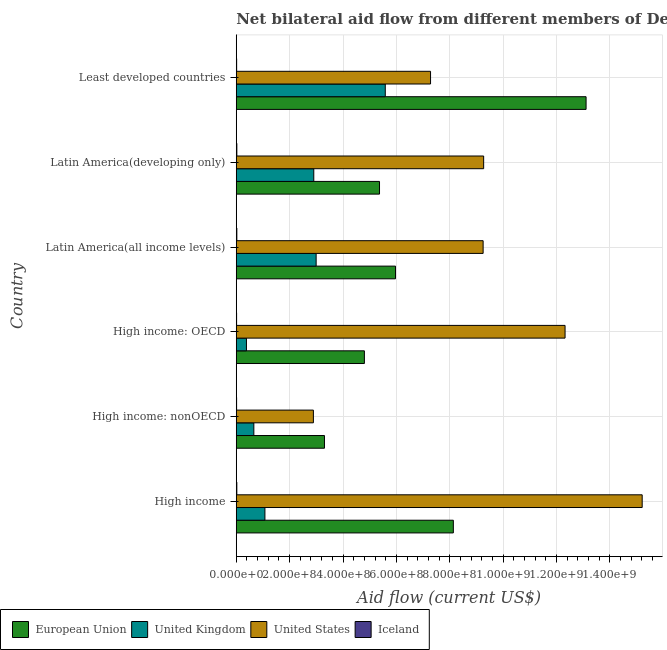How many different coloured bars are there?
Your answer should be very brief. 4. Are the number of bars per tick equal to the number of legend labels?
Provide a short and direct response. Yes. Are the number of bars on each tick of the Y-axis equal?
Ensure brevity in your answer.  Yes. How many bars are there on the 4th tick from the top?
Offer a terse response. 4. How many bars are there on the 3rd tick from the bottom?
Your answer should be compact. 4. What is the label of the 1st group of bars from the top?
Your response must be concise. Least developed countries. What is the amount of aid given by eu in High income: nonOECD?
Provide a succinct answer. 3.30e+08. Across all countries, what is the maximum amount of aid given by iceland?
Make the answer very short. 2.20e+06. Across all countries, what is the minimum amount of aid given by iceland?
Offer a terse response. 1.30e+06. In which country was the amount of aid given by eu maximum?
Provide a short and direct response. Least developed countries. In which country was the amount of aid given by us minimum?
Offer a terse response. High income: nonOECD. What is the total amount of aid given by eu in the graph?
Ensure brevity in your answer.  4.07e+09. What is the difference between the amount of aid given by iceland in High income and that in Latin America(developing only)?
Provide a short and direct response. -2.00e+04. What is the difference between the amount of aid given by us in Latin America(developing only) and the amount of aid given by uk in Latin America(all income levels)?
Offer a very short reply. 6.28e+08. What is the average amount of aid given by eu per country?
Your answer should be compact. 6.78e+08. What is the difference between the amount of aid given by us and amount of aid given by eu in Latin America(developing only)?
Your response must be concise. 3.90e+08. In how many countries, is the amount of aid given by eu greater than 480000000 US$?
Offer a very short reply. 5. What is the ratio of the amount of aid given by eu in High income: nonOECD to that in Least developed countries?
Provide a short and direct response. 0.25. Is the difference between the amount of aid given by eu in High income and High income: nonOECD greater than the difference between the amount of aid given by iceland in High income and High income: nonOECD?
Offer a very short reply. Yes. What is the difference between the highest and the second highest amount of aid given by eu?
Give a very brief answer. 4.97e+08. What is the difference between the highest and the lowest amount of aid given by iceland?
Provide a short and direct response. 9.00e+05. In how many countries, is the amount of aid given by uk greater than the average amount of aid given by uk taken over all countries?
Provide a short and direct response. 3. What does the 4th bar from the top in Latin America(developing only) represents?
Your answer should be compact. European Union. How many bars are there?
Make the answer very short. 24. What is the difference between two consecutive major ticks on the X-axis?
Your answer should be very brief. 2.00e+08. Does the graph contain any zero values?
Keep it short and to the point. No. Does the graph contain grids?
Provide a succinct answer. Yes. How many legend labels are there?
Your answer should be very brief. 4. How are the legend labels stacked?
Give a very brief answer. Horizontal. What is the title of the graph?
Your answer should be compact. Net bilateral aid flow from different members of Development Assistance Committee in the year 1997. What is the label or title of the X-axis?
Offer a very short reply. Aid flow (current US$). What is the Aid flow (current US$) in European Union in High income?
Offer a terse response. 8.13e+08. What is the Aid flow (current US$) of United Kingdom in High income?
Give a very brief answer. 1.07e+08. What is the Aid flow (current US$) of United States in High income?
Provide a succinct answer. 1.52e+09. What is the Aid flow (current US$) of Iceland in High income?
Your answer should be very brief. 2.18e+06. What is the Aid flow (current US$) in European Union in High income: nonOECD?
Make the answer very short. 3.30e+08. What is the Aid flow (current US$) of United Kingdom in High income: nonOECD?
Offer a terse response. 6.59e+07. What is the Aid flow (current US$) in United States in High income: nonOECD?
Keep it short and to the point. 2.89e+08. What is the Aid flow (current US$) in Iceland in High income: nonOECD?
Give a very brief answer. 1.30e+06. What is the Aid flow (current US$) of European Union in High income: OECD?
Offer a very short reply. 4.80e+08. What is the Aid flow (current US$) of United Kingdom in High income: OECD?
Provide a short and direct response. 3.82e+07. What is the Aid flow (current US$) of United States in High income: OECD?
Your answer should be compact. 1.23e+09. What is the Aid flow (current US$) in Iceland in High income: OECD?
Your response must be concise. 1.30e+06. What is the Aid flow (current US$) of European Union in Latin America(all income levels)?
Provide a succinct answer. 5.97e+08. What is the Aid flow (current US$) in United Kingdom in Latin America(all income levels)?
Provide a succinct answer. 2.99e+08. What is the Aid flow (current US$) in United States in Latin America(all income levels)?
Keep it short and to the point. 9.25e+08. What is the Aid flow (current US$) in Iceland in Latin America(all income levels)?
Make the answer very short. 2.20e+06. What is the Aid flow (current US$) of European Union in Latin America(developing only)?
Offer a terse response. 5.37e+08. What is the Aid flow (current US$) of United Kingdom in Latin America(developing only)?
Make the answer very short. 2.90e+08. What is the Aid flow (current US$) of United States in Latin America(developing only)?
Provide a short and direct response. 9.27e+08. What is the Aid flow (current US$) in Iceland in Latin America(developing only)?
Your answer should be very brief. 2.20e+06. What is the Aid flow (current US$) of European Union in Least developed countries?
Your answer should be very brief. 1.31e+09. What is the Aid flow (current US$) in United Kingdom in Least developed countries?
Your answer should be compact. 5.58e+08. What is the Aid flow (current US$) in United States in Least developed countries?
Give a very brief answer. 7.28e+08. What is the Aid flow (current US$) of Iceland in Least developed countries?
Your answer should be compact. 1.46e+06. Across all countries, what is the maximum Aid flow (current US$) of European Union?
Make the answer very short. 1.31e+09. Across all countries, what is the maximum Aid flow (current US$) of United Kingdom?
Your response must be concise. 5.58e+08. Across all countries, what is the maximum Aid flow (current US$) of United States?
Your response must be concise. 1.52e+09. Across all countries, what is the maximum Aid flow (current US$) of Iceland?
Ensure brevity in your answer.  2.20e+06. Across all countries, what is the minimum Aid flow (current US$) of European Union?
Make the answer very short. 3.30e+08. Across all countries, what is the minimum Aid flow (current US$) in United Kingdom?
Your answer should be compact. 3.82e+07. Across all countries, what is the minimum Aid flow (current US$) of United States?
Offer a terse response. 2.89e+08. Across all countries, what is the minimum Aid flow (current US$) of Iceland?
Offer a very short reply. 1.30e+06. What is the total Aid flow (current US$) in European Union in the graph?
Offer a terse response. 4.07e+09. What is the total Aid flow (current US$) of United Kingdom in the graph?
Your response must be concise. 1.36e+09. What is the total Aid flow (current US$) in United States in the graph?
Your answer should be compact. 5.62e+09. What is the total Aid flow (current US$) of Iceland in the graph?
Ensure brevity in your answer.  1.06e+07. What is the difference between the Aid flow (current US$) of European Union in High income and that in High income: nonOECD?
Provide a short and direct response. 4.83e+08. What is the difference between the Aid flow (current US$) in United Kingdom in High income and that in High income: nonOECD?
Ensure brevity in your answer.  4.15e+07. What is the difference between the Aid flow (current US$) of United States in High income and that in High income: nonOECD?
Make the answer very short. 1.23e+09. What is the difference between the Aid flow (current US$) in Iceland in High income and that in High income: nonOECD?
Provide a short and direct response. 8.80e+05. What is the difference between the Aid flow (current US$) in European Union in High income and that in High income: OECD?
Offer a very short reply. 3.33e+08. What is the difference between the Aid flow (current US$) in United Kingdom in High income and that in High income: OECD?
Keep it short and to the point. 6.92e+07. What is the difference between the Aid flow (current US$) of United States in High income and that in High income: OECD?
Give a very brief answer. 2.89e+08. What is the difference between the Aid flow (current US$) in Iceland in High income and that in High income: OECD?
Offer a very short reply. 8.80e+05. What is the difference between the Aid flow (current US$) in European Union in High income and that in Latin America(all income levels)?
Provide a succinct answer. 2.17e+08. What is the difference between the Aid flow (current US$) in United Kingdom in High income and that in Latin America(all income levels)?
Keep it short and to the point. -1.92e+08. What is the difference between the Aid flow (current US$) of United States in High income and that in Latin America(all income levels)?
Your answer should be very brief. 5.96e+08. What is the difference between the Aid flow (current US$) in European Union in High income and that in Latin America(developing only)?
Your response must be concise. 2.77e+08. What is the difference between the Aid flow (current US$) of United Kingdom in High income and that in Latin America(developing only)?
Offer a terse response. -1.83e+08. What is the difference between the Aid flow (current US$) of United States in High income and that in Latin America(developing only)?
Your answer should be very brief. 5.94e+08. What is the difference between the Aid flow (current US$) in Iceland in High income and that in Latin America(developing only)?
Your answer should be compact. -2.00e+04. What is the difference between the Aid flow (current US$) of European Union in High income and that in Least developed countries?
Your response must be concise. -4.97e+08. What is the difference between the Aid flow (current US$) of United Kingdom in High income and that in Least developed countries?
Make the answer very short. -4.51e+08. What is the difference between the Aid flow (current US$) of United States in High income and that in Least developed countries?
Offer a terse response. 7.93e+08. What is the difference between the Aid flow (current US$) in Iceland in High income and that in Least developed countries?
Provide a short and direct response. 7.20e+05. What is the difference between the Aid flow (current US$) of European Union in High income: nonOECD and that in High income: OECD?
Provide a short and direct response. -1.50e+08. What is the difference between the Aid flow (current US$) in United Kingdom in High income: nonOECD and that in High income: OECD?
Your answer should be very brief. 2.76e+07. What is the difference between the Aid flow (current US$) of United States in High income: nonOECD and that in High income: OECD?
Offer a very short reply. -9.43e+08. What is the difference between the Aid flow (current US$) of European Union in High income: nonOECD and that in Latin America(all income levels)?
Your answer should be compact. -2.66e+08. What is the difference between the Aid flow (current US$) of United Kingdom in High income: nonOECD and that in Latin America(all income levels)?
Your response must be concise. -2.33e+08. What is the difference between the Aid flow (current US$) of United States in High income: nonOECD and that in Latin America(all income levels)?
Make the answer very short. -6.36e+08. What is the difference between the Aid flow (current US$) in Iceland in High income: nonOECD and that in Latin America(all income levels)?
Your response must be concise. -9.00e+05. What is the difference between the Aid flow (current US$) in European Union in High income: nonOECD and that in Latin America(developing only)?
Provide a short and direct response. -2.06e+08. What is the difference between the Aid flow (current US$) of United Kingdom in High income: nonOECD and that in Latin America(developing only)?
Your answer should be compact. -2.25e+08. What is the difference between the Aid flow (current US$) in United States in High income: nonOECD and that in Latin America(developing only)?
Provide a succinct answer. -6.38e+08. What is the difference between the Aid flow (current US$) in Iceland in High income: nonOECD and that in Latin America(developing only)?
Ensure brevity in your answer.  -9.00e+05. What is the difference between the Aid flow (current US$) of European Union in High income: nonOECD and that in Least developed countries?
Provide a succinct answer. -9.80e+08. What is the difference between the Aid flow (current US$) in United Kingdom in High income: nonOECD and that in Least developed countries?
Your answer should be compact. -4.92e+08. What is the difference between the Aid flow (current US$) of United States in High income: nonOECD and that in Least developed countries?
Offer a terse response. -4.39e+08. What is the difference between the Aid flow (current US$) of Iceland in High income: nonOECD and that in Least developed countries?
Make the answer very short. -1.60e+05. What is the difference between the Aid flow (current US$) of European Union in High income: OECD and that in Latin America(all income levels)?
Provide a succinct answer. -1.17e+08. What is the difference between the Aid flow (current US$) of United Kingdom in High income: OECD and that in Latin America(all income levels)?
Give a very brief answer. -2.61e+08. What is the difference between the Aid flow (current US$) of United States in High income: OECD and that in Latin America(all income levels)?
Your response must be concise. 3.07e+08. What is the difference between the Aid flow (current US$) of Iceland in High income: OECD and that in Latin America(all income levels)?
Provide a short and direct response. -9.00e+05. What is the difference between the Aid flow (current US$) in European Union in High income: OECD and that in Latin America(developing only)?
Your answer should be very brief. -5.67e+07. What is the difference between the Aid flow (current US$) in United Kingdom in High income: OECD and that in Latin America(developing only)?
Your response must be concise. -2.52e+08. What is the difference between the Aid flow (current US$) of United States in High income: OECD and that in Latin America(developing only)?
Keep it short and to the point. 3.05e+08. What is the difference between the Aid flow (current US$) in Iceland in High income: OECD and that in Latin America(developing only)?
Provide a short and direct response. -9.00e+05. What is the difference between the Aid flow (current US$) of European Union in High income: OECD and that in Least developed countries?
Ensure brevity in your answer.  -8.31e+08. What is the difference between the Aid flow (current US$) in United Kingdom in High income: OECD and that in Least developed countries?
Your response must be concise. -5.20e+08. What is the difference between the Aid flow (current US$) in United States in High income: OECD and that in Least developed countries?
Give a very brief answer. 5.04e+08. What is the difference between the Aid flow (current US$) of European Union in Latin America(all income levels) and that in Latin America(developing only)?
Offer a terse response. 5.99e+07. What is the difference between the Aid flow (current US$) in United Kingdom in Latin America(all income levels) and that in Latin America(developing only)?
Provide a short and direct response. 8.87e+06. What is the difference between the Aid flow (current US$) in European Union in Latin America(all income levels) and that in Least developed countries?
Give a very brief answer. -7.14e+08. What is the difference between the Aid flow (current US$) of United Kingdom in Latin America(all income levels) and that in Least developed countries?
Your response must be concise. -2.59e+08. What is the difference between the Aid flow (current US$) in United States in Latin America(all income levels) and that in Least developed countries?
Offer a terse response. 1.97e+08. What is the difference between the Aid flow (current US$) in Iceland in Latin America(all income levels) and that in Least developed countries?
Make the answer very short. 7.40e+05. What is the difference between the Aid flow (current US$) of European Union in Latin America(developing only) and that in Least developed countries?
Your answer should be compact. -7.74e+08. What is the difference between the Aid flow (current US$) of United Kingdom in Latin America(developing only) and that in Least developed countries?
Keep it short and to the point. -2.68e+08. What is the difference between the Aid flow (current US$) in United States in Latin America(developing only) and that in Least developed countries?
Your answer should be compact. 1.99e+08. What is the difference between the Aid flow (current US$) in Iceland in Latin America(developing only) and that in Least developed countries?
Make the answer very short. 7.40e+05. What is the difference between the Aid flow (current US$) of European Union in High income and the Aid flow (current US$) of United Kingdom in High income: nonOECD?
Your answer should be compact. 7.48e+08. What is the difference between the Aid flow (current US$) of European Union in High income and the Aid flow (current US$) of United States in High income: nonOECD?
Give a very brief answer. 5.24e+08. What is the difference between the Aid flow (current US$) of European Union in High income and the Aid flow (current US$) of Iceland in High income: nonOECD?
Keep it short and to the point. 8.12e+08. What is the difference between the Aid flow (current US$) of United Kingdom in High income and the Aid flow (current US$) of United States in High income: nonOECD?
Your answer should be very brief. -1.82e+08. What is the difference between the Aid flow (current US$) in United Kingdom in High income and the Aid flow (current US$) in Iceland in High income: nonOECD?
Ensure brevity in your answer.  1.06e+08. What is the difference between the Aid flow (current US$) of United States in High income and the Aid flow (current US$) of Iceland in High income: nonOECD?
Provide a succinct answer. 1.52e+09. What is the difference between the Aid flow (current US$) of European Union in High income and the Aid flow (current US$) of United Kingdom in High income: OECD?
Provide a succinct answer. 7.75e+08. What is the difference between the Aid flow (current US$) of European Union in High income and the Aid flow (current US$) of United States in High income: OECD?
Your answer should be compact. -4.19e+08. What is the difference between the Aid flow (current US$) of European Union in High income and the Aid flow (current US$) of Iceland in High income: OECD?
Your answer should be compact. 8.12e+08. What is the difference between the Aid flow (current US$) of United Kingdom in High income and the Aid flow (current US$) of United States in High income: OECD?
Give a very brief answer. -1.12e+09. What is the difference between the Aid flow (current US$) in United Kingdom in High income and the Aid flow (current US$) in Iceland in High income: OECD?
Your response must be concise. 1.06e+08. What is the difference between the Aid flow (current US$) in United States in High income and the Aid flow (current US$) in Iceland in High income: OECD?
Give a very brief answer. 1.52e+09. What is the difference between the Aid flow (current US$) in European Union in High income and the Aid flow (current US$) in United Kingdom in Latin America(all income levels)?
Give a very brief answer. 5.14e+08. What is the difference between the Aid flow (current US$) of European Union in High income and the Aid flow (current US$) of United States in Latin America(all income levels)?
Offer a very short reply. -1.12e+08. What is the difference between the Aid flow (current US$) of European Union in High income and the Aid flow (current US$) of Iceland in Latin America(all income levels)?
Keep it short and to the point. 8.11e+08. What is the difference between the Aid flow (current US$) of United Kingdom in High income and the Aid flow (current US$) of United States in Latin America(all income levels)?
Your answer should be very brief. -8.18e+08. What is the difference between the Aid flow (current US$) of United Kingdom in High income and the Aid flow (current US$) of Iceland in Latin America(all income levels)?
Provide a succinct answer. 1.05e+08. What is the difference between the Aid flow (current US$) of United States in High income and the Aid flow (current US$) of Iceland in Latin America(all income levels)?
Your response must be concise. 1.52e+09. What is the difference between the Aid flow (current US$) in European Union in High income and the Aid flow (current US$) in United Kingdom in Latin America(developing only)?
Your answer should be very brief. 5.23e+08. What is the difference between the Aid flow (current US$) of European Union in High income and the Aid flow (current US$) of United States in Latin America(developing only)?
Give a very brief answer. -1.14e+08. What is the difference between the Aid flow (current US$) of European Union in High income and the Aid flow (current US$) of Iceland in Latin America(developing only)?
Offer a very short reply. 8.11e+08. What is the difference between the Aid flow (current US$) of United Kingdom in High income and the Aid flow (current US$) of United States in Latin America(developing only)?
Your answer should be very brief. -8.20e+08. What is the difference between the Aid flow (current US$) of United Kingdom in High income and the Aid flow (current US$) of Iceland in Latin America(developing only)?
Offer a very short reply. 1.05e+08. What is the difference between the Aid flow (current US$) of United States in High income and the Aid flow (current US$) of Iceland in Latin America(developing only)?
Give a very brief answer. 1.52e+09. What is the difference between the Aid flow (current US$) of European Union in High income and the Aid flow (current US$) of United Kingdom in Least developed countries?
Ensure brevity in your answer.  2.55e+08. What is the difference between the Aid flow (current US$) of European Union in High income and the Aid flow (current US$) of United States in Least developed countries?
Make the answer very short. 8.54e+07. What is the difference between the Aid flow (current US$) in European Union in High income and the Aid flow (current US$) in Iceland in Least developed countries?
Offer a very short reply. 8.12e+08. What is the difference between the Aid flow (current US$) in United Kingdom in High income and the Aid flow (current US$) in United States in Least developed countries?
Offer a very short reply. -6.21e+08. What is the difference between the Aid flow (current US$) of United Kingdom in High income and the Aid flow (current US$) of Iceland in Least developed countries?
Your answer should be very brief. 1.06e+08. What is the difference between the Aid flow (current US$) of United States in High income and the Aid flow (current US$) of Iceland in Least developed countries?
Offer a terse response. 1.52e+09. What is the difference between the Aid flow (current US$) in European Union in High income: nonOECD and the Aid flow (current US$) in United Kingdom in High income: OECD?
Provide a succinct answer. 2.92e+08. What is the difference between the Aid flow (current US$) in European Union in High income: nonOECD and the Aid flow (current US$) in United States in High income: OECD?
Provide a short and direct response. -9.02e+08. What is the difference between the Aid flow (current US$) in European Union in High income: nonOECD and the Aid flow (current US$) in Iceland in High income: OECD?
Ensure brevity in your answer.  3.29e+08. What is the difference between the Aid flow (current US$) in United Kingdom in High income: nonOECD and the Aid flow (current US$) in United States in High income: OECD?
Your answer should be compact. -1.17e+09. What is the difference between the Aid flow (current US$) in United Kingdom in High income: nonOECD and the Aid flow (current US$) in Iceland in High income: OECD?
Offer a terse response. 6.46e+07. What is the difference between the Aid flow (current US$) of United States in High income: nonOECD and the Aid flow (current US$) of Iceland in High income: OECD?
Keep it short and to the point. 2.88e+08. What is the difference between the Aid flow (current US$) of European Union in High income: nonOECD and the Aid flow (current US$) of United Kingdom in Latin America(all income levels)?
Your response must be concise. 3.12e+07. What is the difference between the Aid flow (current US$) in European Union in High income: nonOECD and the Aid flow (current US$) in United States in Latin America(all income levels)?
Your answer should be compact. -5.94e+08. What is the difference between the Aid flow (current US$) of European Union in High income: nonOECD and the Aid flow (current US$) of Iceland in Latin America(all income levels)?
Your response must be concise. 3.28e+08. What is the difference between the Aid flow (current US$) of United Kingdom in High income: nonOECD and the Aid flow (current US$) of United States in Latin America(all income levels)?
Your answer should be very brief. -8.59e+08. What is the difference between the Aid flow (current US$) in United Kingdom in High income: nonOECD and the Aid flow (current US$) in Iceland in Latin America(all income levels)?
Give a very brief answer. 6.37e+07. What is the difference between the Aid flow (current US$) in United States in High income: nonOECD and the Aid flow (current US$) in Iceland in Latin America(all income levels)?
Provide a succinct answer. 2.87e+08. What is the difference between the Aid flow (current US$) of European Union in High income: nonOECD and the Aid flow (current US$) of United Kingdom in Latin America(developing only)?
Ensure brevity in your answer.  4.00e+07. What is the difference between the Aid flow (current US$) of European Union in High income: nonOECD and the Aid flow (current US$) of United States in Latin America(developing only)?
Provide a succinct answer. -5.96e+08. What is the difference between the Aid flow (current US$) of European Union in High income: nonOECD and the Aid flow (current US$) of Iceland in Latin America(developing only)?
Provide a succinct answer. 3.28e+08. What is the difference between the Aid flow (current US$) of United Kingdom in High income: nonOECD and the Aid flow (current US$) of United States in Latin America(developing only)?
Offer a terse response. -8.61e+08. What is the difference between the Aid flow (current US$) in United Kingdom in High income: nonOECD and the Aid flow (current US$) in Iceland in Latin America(developing only)?
Your answer should be compact. 6.37e+07. What is the difference between the Aid flow (current US$) of United States in High income: nonOECD and the Aid flow (current US$) of Iceland in Latin America(developing only)?
Offer a terse response. 2.87e+08. What is the difference between the Aid flow (current US$) in European Union in High income: nonOECD and the Aid flow (current US$) in United Kingdom in Least developed countries?
Keep it short and to the point. -2.28e+08. What is the difference between the Aid flow (current US$) of European Union in High income: nonOECD and the Aid flow (current US$) of United States in Least developed countries?
Make the answer very short. -3.98e+08. What is the difference between the Aid flow (current US$) of European Union in High income: nonOECD and the Aid flow (current US$) of Iceland in Least developed countries?
Give a very brief answer. 3.29e+08. What is the difference between the Aid flow (current US$) of United Kingdom in High income: nonOECD and the Aid flow (current US$) of United States in Least developed countries?
Make the answer very short. -6.62e+08. What is the difference between the Aid flow (current US$) of United Kingdom in High income: nonOECD and the Aid flow (current US$) of Iceland in Least developed countries?
Provide a succinct answer. 6.44e+07. What is the difference between the Aid flow (current US$) of United States in High income: nonOECD and the Aid flow (current US$) of Iceland in Least developed countries?
Offer a terse response. 2.88e+08. What is the difference between the Aid flow (current US$) in European Union in High income: OECD and the Aid flow (current US$) in United Kingdom in Latin America(all income levels)?
Your answer should be very brief. 1.81e+08. What is the difference between the Aid flow (current US$) in European Union in High income: OECD and the Aid flow (current US$) in United States in Latin America(all income levels)?
Make the answer very short. -4.45e+08. What is the difference between the Aid flow (current US$) of European Union in High income: OECD and the Aid flow (current US$) of Iceland in Latin America(all income levels)?
Provide a short and direct response. 4.78e+08. What is the difference between the Aid flow (current US$) in United Kingdom in High income: OECD and the Aid flow (current US$) in United States in Latin America(all income levels)?
Ensure brevity in your answer.  -8.87e+08. What is the difference between the Aid flow (current US$) in United Kingdom in High income: OECD and the Aid flow (current US$) in Iceland in Latin America(all income levels)?
Keep it short and to the point. 3.60e+07. What is the difference between the Aid flow (current US$) in United States in High income: OECD and the Aid flow (current US$) in Iceland in Latin America(all income levels)?
Offer a terse response. 1.23e+09. What is the difference between the Aid flow (current US$) of European Union in High income: OECD and the Aid flow (current US$) of United Kingdom in Latin America(developing only)?
Your answer should be compact. 1.90e+08. What is the difference between the Aid flow (current US$) of European Union in High income: OECD and the Aid flow (current US$) of United States in Latin America(developing only)?
Provide a short and direct response. -4.47e+08. What is the difference between the Aid flow (current US$) in European Union in High income: OECD and the Aid flow (current US$) in Iceland in Latin America(developing only)?
Your response must be concise. 4.78e+08. What is the difference between the Aid flow (current US$) of United Kingdom in High income: OECD and the Aid flow (current US$) of United States in Latin America(developing only)?
Offer a terse response. -8.89e+08. What is the difference between the Aid flow (current US$) in United Kingdom in High income: OECD and the Aid flow (current US$) in Iceland in Latin America(developing only)?
Your answer should be very brief. 3.60e+07. What is the difference between the Aid flow (current US$) in United States in High income: OECD and the Aid flow (current US$) in Iceland in Latin America(developing only)?
Provide a succinct answer. 1.23e+09. What is the difference between the Aid flow (current US$) of European Union in High income: OECD and the Aid flow (current US$) of United Kingdom in Least developed countries?
Your response must be concise. -7.83e+07. What is the difference between the Aid flow (current US$) of European Union in High income: OECD and the Aid flow (current US$) of United States in Least developed countries?
Make the answer very short. -2.48e+08. What is the difference between the Aid flow (current US$) in European Union in High income: OECD and the Aid flow (current US$) in Iceland in Least developed countries?
Keep it short and to the point. 4.79e+08. What is the difference between the Aid flow (current US$) of United Kingdom in High income: OECD and the Aid flow (current US$) of United States in Least developed countries?
Provide a short and direct response. -6.90e+08. What is the difference between the Aid flow (current US$) in United Kingdom in High income: OECD and the Aid flow (current US$) in Iceland in Least developed countries?
Provide a short and direct response. 3.68e+07. What is the difference between the Aid flow (current US$) of United States in High income: OECD and the Aid flow (current US$) of Iceland in Least developed countries?
Provide a short and direct response. 1.23e+09. What is the difference between the Aid flow (current US$) of European Union in Latin America(all income levels) and the Aid flow (current US$) of United Kingdom in Latin America(developing only)?
Provide a short and direct response. 3.06e+08. What is the difference between the Aid flow (current US$) in European Union in Latin America(all income levels) and the Aid flow (current US$) in United States in Latin America(developing only)?
Your answer should be very brief. -3.30e+08. What is the difference between the Aid flow (current US$) in European Union in Latin America(all income levels) and the Aid flow (current US$) in Iceland in Latin America(developing only)?
Provide a succinct answer. 5.95e+08. What is the difference between the Aid flow (current US$) in United Kingdom in Latin America(all income levels) and the Aid flow (current US$) in United States in Latin America(developing only)?
Ensure brevity in your answer.  -6.28e+08. What is the difference between the Aid flow (current US$) in United Kingdom in Latin America(all income levels) and the Aid flow (current US$) in Iceland in Latin America(developing only)?
Offer a very short reply. 2.97e+08. What is the difference between the Aid flow (current US$) in United States in Latin America(all income levels) and the Aid flow (current US$) in Iceland in Latin America(developing only)?
Provide a short and direct response. 9.23e+08. What is the difference between the Aid flow (current US$) in European Union in Latin America(all income levels) and the Aid flow (current US$) in United Kingdom in Least developed countries?
Offer a very short reply. 3.83e+07. What is the difference between the Aid flow (current US$) of European Union in Latin America(all income levels) and the Aid flow (current US$) of United States in Least developed countries?
Offer a very short reply. -1.31e+08. What is the difference between the Aid flow (current US$) in European Union in Latin America(all income levels) and the Aid flow (current US$) in Iceland in Least developed countries?
Give a very brief answer. 5.95e+08. What is the difference between the Aid flow (current US$) in United Kingdom in Latin America(all income levels) and the Aid flow (current US$) in United States in Least developed countries?
Offer a terse response. -4.29e+08. What is the difference between the Aid flow (current US$) in United Kingdom in Latin America(all income levels) and the Aid flow (current US$) in Iceland in Least developed countries?
Provide a short and direct response. 2.98e+08. What is the difference between the Aid flow (current US$) of United States in Latin America(all income levels) and the Aid flow (current US$) of Iceland in Least developed countries?
Give a very brief answer. 9.24e+08. What is the difference between the Aid flow (current US$) in European Union in Latin America(developing only) and the Aid flow (current US$) in United Kingdom in Least developed countries?
Ensure brevity in your answer.  -2.16e+07. What is the difference between the Aid flow (current US$) in European Union in Latin America(developing only) and the Aid flow (current US$) in United States in Least developed countries?
Your answer should be compact. -1.91e+08. What is the difference between the Aid flow (current US$) of European Union in Latin America(developing only) and the Aid flow (current US$) of Iceland in Least developed countries?
Provide a succinct answer. 5.35e+08. What is the difference between the Aid flow (current US$) of United Kingdom in Latin America(developing only) and the Aid flow (current US$) of United States in Least developed countries?
Your answer should be compact. -4.38e+08. What is the difference between the Aid flow (current US$) in United Kingdom in Latin America(developing only) and the Aid flow (current US$) in Iceland in Least developed countries?
Your response must be concise. 2.89e+08. What is the difference between the Aid flow (current US$) of United States in Latin America(developing only) and the Aid flow (current US$) of Iceland in Least developed countries?
Make the answer very short. 9.26e+08. What is the average Aid flow (current US$) in European Union per country?
Provide a succinct answer. 6.78e+08. What is the average Aid flow (current US$) in United Kingdom per country?
Provide a succinct answer. 2.27e+08. What is the average Aid flow (current US$) in United States per country?
Provide a succinct answer. 9.37e+08. What is the average Aid flow (current US$) of Iceland per country?
Keep it short and to the point. 1.77e+06. What is the difference between the Aid flow (current US$) in European Union and Aid flow (current US$) in United Kingdom in High income?
Your response must be concise. 7.06e+08. What is the difference between the Aid flow (current US$) in European Union and Aid flow (current US$) in United States in High income?
Provide a succinct answer. -7.08e+08. What is the difference between the Aid flow (current US$) of European Union and Aid flow (current US$) of Iceland in High income?
Provide a succinct answer. 8.11e+08. What is the difference between the Aid flow (current US$) in United Kingdom and Aid flow (current US$) in United States in High income?
Your response must be concise. -1.41e+09. What is the difference between the Aid flow (current US$) in United Kingdom and Aid flow (current US$) in Iceland in High income?
Provide a short and direct response. 1.05e+08. What is the difference between the Aid flow (current US$) of United States and Aid flow (current US$) of Iceland in High income?
Provide a short and direct response. 1.52e+09. What is the difference between the Aid flow (current US$) in European Union and Aid flow (current US$) in United Kingdom in High income: nonOECD?
Ensure brevity in your answer.  2.65e+08. What is the difference between the Aid flow (current US$) in European Union and Aid flow (current US$) in United States in High income: nonOECD?
Your answer should be very brief. 4.15e+07. What is the difference between the Aid flow (current US$) of European Union and Aid flow (current US$) of Iceland in High income: nonOECD?
Provide a succinct answer. 3.29e+08. What is the difference between the Aid flow (current US$) in United Kingdom and Aid flow (current US$) in United States in High income: nonOECD?
Your response must be concise. -2.23e+08. What is the difference between the Aid flow (current US$) in United Kingdom and Aid flow (current US$) in Iceland in High income: nonOECD?
Offer a terse response. 6.46e+07. What is the difference between the Aid flow (current US$) of United States and Aid flow (current US$) of Iceland in High income: nonOECD?
Ensure brevity in your answer.  2.88e+08. What is the difference between the Aid flow (current US$) of European Union and Aid flow (current US$) of United Kingdom in High income: OECD?
Your answer should be very brief. 4.42e+08. What is the difference between the Aid flow (current US$) in European Union and Aid flow (current US$) in United States in High income: OECD?
Offer a very short reply. -7.52e+08. What is the difference between the Aid flow (current US$) in European Union and Aid flow (current US$) in Iceland in High income: OECD?
Make the answer very short. 4.79e+08. What is the difference between the Aid flow (current US$) of United Kingdom and Aid flow (current US$) of United States in High income: OECD?
Your answer should be very brief. -1.19e+09. What is the difference between the Aid flow (current US$) of United Kingdom and Aid flow (current US$) of Iceland in High income: OECD?
Offer a terse response. 3.69e+07. What is the difference between the Aid flow (current US$) of United States and Aid flow (current US$) of Iceland in High income: OECD?
Provide a succinct answer. 1.23e+09. What is the difference between the Aid flow (current US$) of European Union and Aid flow (current US$) of United Kingdom in Latin America(all income levels)?
Offer a very short reply. 2.97e+08. What is the difference between the Aid flow (current US$) in European Union and Aid flow (current US$) in United States in Latin America(all income levels)?
Offer a very short reply. -3.28e+08. What is the difference between the Aid flow (current US$) of European Union and Aid flow (current US$) of Iceland in Latin America(all income levels)?
Give a very brief answer. 5.95e+08. What is the difference between the Aid flow (current US$) of United Kingdom and Aid flow (current US$) of United States in Latin America(all income levels)?
Keep it short and to the point. -6.26e+08. What is the difference between the Aid flow (current US$) of United Kingdom and Aid flow (current US$) of Iceland in Latin America(all income levels)?
Ensure brevity in your answer.  2.97e+08. What is the difference between the Aid flow (current US$) of United States and Aid flow (current US$) of Iceland in Latin America(all income levels)?
Ensure brevity in your answer.  9.23e+08. What is the difference between the Aid flow (current US$) in European Union and Aid flow (current US$) in United Kingdom in Latin America(developing only)?
Ensure brevity in your answer.  2.46e+08. What is the difference between the Aid flow (current US$) in European Union and Aid flow (current US$) in United States in Latin America(developing only)?
Give a very brief answer. -3.90e+08. What is the difference between the Aid flow (current US$) in European Union and Aid flow (current US$) in Iceland in Latin America(developing only)?
Your answer should be very brief. 5.35e+08. What is the difference between the Aid flow (current US$) of United Kingdom and Aid flow (current US$) of United States in Latin America(developing only)?
Your response must be concise. -6.37e+08. What is the difference between the Aid flow (current US$) in United Kingdom and Aid flow (current US$) in Iceland in Latin America(developing only)?
Offer a terse response. 2.88e+08. What is the difference between the Aid flow (current US$) in United States and Aid flow (current US$) in Iceland in Latin America(developing only)?
Make the answer very short. 9.25e+08. What is the difference between the Aid flow (current US$) in European Union and Aid flow (current US$) in United Kingdom in Least developed countries?
Your answer should be very brief. 7.52e+08. What is the difference between the Aid flow (current US$) in European Union and Aid flow (current US$) in United States in Least developed countries?
Offer a very short reply. 5.83e+08. What is the difference between the Aid flow (current US$) in European Union and Aid flow (current US$) in Iceland in Least developed countries?
Provide a short and direct response. 1.31e+09. What is the difference between the Aid flow (current US$) in United Kingdom and Aid flow (current US$) in United States in Least developed countries?
Keep it short and to the point. -1.70e+08. What is the difference between the Aid flow (current US$) of United Kingdom and Aid flow (current US$) of Iceland in Least developed countries?
Your answer should be compact. 5.57e+08. What is the difference between the Aid flow (current US$) of United States and Aid flow (current US$) of Iceland in Least developed countries?
Offer a terse response. 7.27e+08. What is the ratio of the Aid flow (current US$) in European Union in High income to that in High income: nonOECD?
Provide a succinct answer. 2.46. What is the ratio of the Aid flow (current US$) in United Kingdom in High income to that in High income: nonOECD?
Give a very brief answer. 1.63. What is the ratio of the Aid flow (current US$) of United States in High income to that in High income: nonOECD?
Make the answer very short. 5.26. What is the ratio of the Aid flow (current US$) of Iceland in High income to that in High income: nonOECD?
Make the answer very short. 1.68. What is the ratio of the Aid flow (current US$) of European Union in High income to that in High income: OECD?
Offer a terse response. 1.69. What is the ratio of the Aid flow (current US$) of United Kingdom in High income to that in High income: OECD?
Provide a short and direct response. 2.81. What is the ratio of the Aid flow (current US$) of United States in High income to that in High income: OECD?
Keep it short and to the point. 1.23. What is the ratio of the Aid flow (current US$) of Iceland in High income to that in High income: OECD?
Your answer should be compact. 1.68. What is the ratio of the Aid flow (current US$) of European Union in High income to that in Latin America(all income levels)?
Your answer should be very brief. 1.36. What is the ratio of the Aid flow (current US$) in United Kingdom in High income to that in Latin America(all income levels)?
Your response must be concise. 0.36. What is the ratio of the Aid flow (current US$) of United States in High income to that in Latin America(all income levels)?
Your answer should be compact. 1.64. What is the ratio of the Aid flow (current US$) in Iceland in High income to that in Latin America(all income levels)?
Your response must be concise. 0.99. What is the ratio of the Aid flow (current US$) of European Union in High income to that in Latin America(developing only)?
Give a very brief answer. 1.52. What is the ratio of the Aid flow (current US$) of United Kingdom in High income to that in Latin America(developing only)?
Keep it short and to the point. 0.37. What is the ratio of the Aid flow (current US$) in United States in High income to that in Latin America(developing only)?
Provide a short and direct response. 1.64. What is the ratio of the Aid flow (current US$) of Iceland in High income to that in Latin America(developing only)?
Ensure brevity in your answer.  0.99. What is the ratio of the Aid flow (current US$) in European Union in High income to that in Least developed countries?
Your answer should be compact. 0.62. What is the ratio of the Aid flow (current US$) in United Kingdom in High income to that in Least developed countries?
Your answer should be compact. 0.19. What is the ratio of the Aid flow (current US$) in United States in High income to that in Least developed countries?
Offer a terse response. 2.09. What is the ratio of the Aid flow (current US$) in Iceland in High income to that in Least developed countries?
Offer a very short reply. 1.49. What is the ratio of the Aid flow (current US$) of European Union in High income: nonOECD to that in High income: OECD?
Offer a very short reply. 0.69. What is the ratio of the Aid flow (current US$) in United Kingdom in High income: nonOECD to that in High income: OECD?
Give a very brief answer. 1.72. What is the ratio of the Aid flow (current US$) of United States in High income: nonOECD to that in High income: OECD?
Provide a short and direct response. 0.23. What is the ratio of the Aid flow (current US$) in Iceland in High income: nonOECD to that in High income: OECD?
Make the answer very short. 1. What is the ratio of the Aid flow (current US$) of European Union in High income: nonOECD to that in Latin America(all income levels)?
Give a very brief answer. 0.55. What is the ratio of the Aid flow (current US$) of United Kingdom in High income: nonOECD to that in Latin America(all income levels)?
Provide a succinct answer. 0.22. What is the ratio of the Aid flow (current US$) of United States in High income: nonOECD to that in Latin America(all income levels)?
Provide a succinct answer. 0.31. What is the ratio of the Aid flow (current US$) in Iceland in High income: nonOECD to that in Latin America(all income levels)?
Offer a very short reply. 0.59. What is the ratio of the Aid flow (current US$) in European Union in High income: nonOECD to that in Latin America(developing only)?
Offer a terse response. 0.62. What is the ratio of the Aid flow (current US$) in United Kingdom in High income: nonOECD to that in Latin America(developing only)?
Your response must be concise. 0.23. What is the ratio of the Aid flow (current US$) of United States in High income: nonOECD to that in Latin America(developing only)?
Provide a succinct answer. 0.31. What is the ratio of the Aid flow (current US$) in Iceland in High income: nonOECD to that in Latin America(developing only)?
Your answer should be very brief. 0.59. What is the ratio of the Aid flow (current US$) of European Union in High income: nonOECD to that in Least developed countries?
Offer a terse response. 0.25. What is the ratio of the Aid flow (current US$) in United Kingdom in High income: nonOECD to that in Least developed countries?
Make the answer very short. 0.12. What is the ratio of the Aid flow (current US$) of United States in High income: nonOECD to that in Least developed countries?
Make the answer very short. 0.4. What is the ratio of the Aid flow (current US$) in Iceland in High income: nonOECD to that in Least developed countries?
Offer a terse response. 0.89. What is the ratio of the Aid flow (current US$) of European Union in High income: OECD to that in Latin America(all income levels)?
Offer a terse response. 0.8. What is the ratio of the Aid flow (current US$) in United Kingdom in High income: OECD to that in Latin America(all income levels)?
Your answer should be compact. 0.13. What is the ratio of the Aid flow (current US$) of United States in High income: OECD to that in Latin America(all income levels)?
Your answer should be compact. 1.33. What is the ratio of the Aid flow (current US$) of Iceland in High income: OECD to that in Latin America(all income levels)?
Offer a terse response. 0.59. What is the ratio of the Aid flow (current US$) in European Union in High income: OECD to that in Latin America(developing only)?
Your answer should be very brief. 0.89. What is the ratio of the Aid flow (current US$) of United Kingdom in High income: OECD to that in Latin America(developing only)?
Keep it short and to the point. 0.13. What is the ratio of the Aid flow (current US$) of United States in High income: OECD to that in Latin America(developing only)?
Keep it short and to the point. 1.33. What is the ratio of the Aid flow (current US$) of Iceland in High income: OECD to that in Latin America(developing only)?
Give a very brief answer. 0.59. What is the ratio of the Aid flow (current US$) in European Union in High income: OECD to that in Least developed countries?
Your answer should be very brief. 0.37. What is the ratio of the Aid flow (current US$) in United Kingdom in High income: OECD to that in Least developed countries?
Offer a very short reply. 0.07. What is the ratio of the Aid flow (current US$) of United States in High income: OECD to that in Least developed countries?
Offer a very short reply. 1.69. What is the ratio of the Aid flow (current US$) of Iceland in High income: OECD to that in Least developed countries?
Your answer should be compact. 0.89. What is the ratio of the Aid flow (current US$) in European Union in Latin America(all income levels) to that in Latin America(developing only)?
Provide a succinct answer. 1.11. What is the ratio of the Aid flow (current US$) in United Kingdom in Latin America(all income levels) to that in Latin America(developing only)?
Ensure brevity in your answer.  1.03. What is the ratio of the Aid flow (current US$) of United States in Latin America(all income levels) to that in Latin America(developing only)?
Give a very brief answer. 1. What is the ratio of the Aid flow (current US$) of Iceland in Latin America(all income levels) to that in Latin America(developing only)?
Keep it short and to the point. 1. What is the ratio of the Aid flow (current US$) of European Union in Latin America(all income levels) to that in Least developed countries?
Keep it short and to the point. 0.46. What is the ratio of the Aid flow (current US$) of United Kingdom in Latin America(all income levels) to that in Least developed countries?
Give a very brief answer. 0.54. What is the ratio of the Aid flow (current US$) of United States in Latin America(all income levels) to that in Least developed countries?
Offer a very short reply. 1.27. What is the ratio of the Aid flow (current US$) of Iceland in Latin America(all income levels) to that in Least developed countries?
Provide a succinct answer. 1.51. What is the ratio of the Aid flow (current US$) in European Union in Latin America(developing only) to that in Least developed countries?
Give a very brief answer. 0.41. What is the ratio of the Aid flow (current US$) in United Kingdom in Latin America(developing only) to that in Least developed countries?
Provide a succinct answer. 0.52. What is the ratio of the Aid flow (current US$) in United States in Latin America(developing only) to that in Least developed countries?
Make the answer very short. 1.27. What is the ratio of the Aid flow (current US$) of Iceland in Latin America(developing only) to that in Least developed countries?
Ensure brevity in your answer.  1.51. What is the difference between the highest and the second highest Aid flow (current US$) of European Union?
Your answer should be very brief. 4.97e+08. What is the difference between the highest and the second highest Aid flow (current US$) of United Kingdom?
Keep it short and to the point. 2.59e+08. What is the difference between the highest and the second highest Aid flow (current US$) of United States?
Give a very brief answer. 2.89e+08. What is the difference between the highest and the lowest Aid flow (current US$) in European Union?
Provide a short and direct response. 9.80e+08. What is the difference between the highest and the lowest Aid flow (current US$) in United Kingdom?
Provide a short and direct response. 5.20e+08. What is the difference between the highest and the lowest Aid flow (current US$) in United States?
Provide a succinct answer. 1.23e+09. 